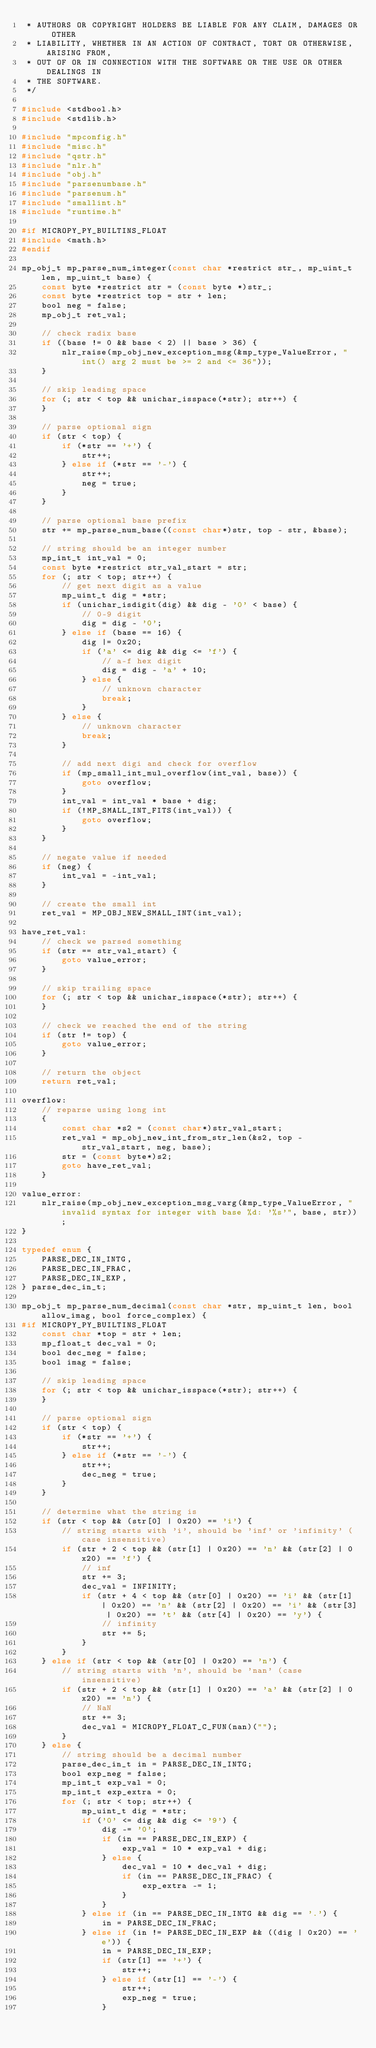Convert code to text. <code><loc_0><loc_0><loc_500><loc_500><_C_> * AUTHORS OR COPYRIGHT HOLDERS BE LIABLE FOR ANY CLAIM, DAMAGES OR OTHER
 * LIABILITY, WHETHER IN AN ACTION OF CONTRACT, TORT OR OTHERWISE, ARISING FROM,
 * OUT OF OR IN CONNECTION WITH THE SOFTWARE OR THE USE OR OTHER DEALINGS IN
 * THE SOFTWARE.
 */

#include <stdbool.h>
#include <stdlib.h>

#include "mpconfig.h"
#include "misc.h"
#include "qstr.h"
#include "nlr.h"
#include "obj.h"
#include "parsenumbase.h"
#include "parsenum.h"
#include "smallint.h"
#include "runtime.h"

#if MICROPY_PY_BUILTINS_FLOAT
#include <math.h>
#endif

mp_obj_t mp_parse_num_integer(const char *restrict str_, mp_uint_t len, mp_uint_t base) {
    const byte *restrict str = (const byte *)str_;
    const byte *restrict top = str + len;
    bool neg = false;
    mp_obj_t ret_val;

    // check radix base
    if ((base != 0 && base < 2) || base > 36) {
        nlr_raise(mp_obj_new_exception_msg(&mp_type_ValueError, "int() arg 2 must be >= 2 and <= 36"));
    }

    // skip leading space
    for (; str < top && unichar_isspace(*str); str++) {
    }

    // parse optional sign
    if (str < top) {
        if (*str == '+') {
            str++;
        } else if (*str == '-') {
            str++;
            neg = true;
        }
    }

    // parse optional base prefix
    str += mp_parse_num_base((const char*)str, top - str, &base);

    // string should be an integer number
    mp_int_t int_val = 0;
    const byte *restrict str_val_start = str;
    for (; str < top; str++) {
        // get next digit as a value
        mp_uint_t dig = *str;
        if (unichar_isdigit(dig) && dig - '0' < base) {
            // 0-9 digit
            dig = dig - '0';
        } else if (base == 16) {
            dig |= 0x20;
            if ('a' <= dig && dig <= 'f') {
                // a-f hex digit
                dig = dig - 'a' + 10;
            } else {
                // unknown character
                break;
            }
        } else {
            // unknown character
            break;
        }

        // add next digi and check for overflow
        if (mp_small_int_mul_overflow(int_val, base)) {
            goto overflow;
        }
        int_val = int_val * base + dig;
        if (!MP_SMALL_INT_FITS(int_val)) {
            goto overflow;
        }
    }

    // negate value if needed
    if (neg) {
        int_val = -int_val;
    }

    // create the small int
    ret_val = MP_OBJ_NEW_SMALL_INT(int_val);

have_ret_val:
    // check we parsed something
    if (str == str_val_start) {
        goto value_error;
    }

    // skip trailing space
    for (; str < top && unichar_isspace(*str); str++) {
    }

    // check we reached the end of the string
    if (str != top) {
        goto value_error;
    }

    // return the object
    return ret_val;

overflow:
    // reparse using long int
    {
        const char *s2 = (const char*)str_val_start;
        ret_val = mp_obj_new_int_from_str_len(&s2, top - str_val_start, neg, base);
        str = (const byte*)s2;
        goto have_ret_val;
    }

value_error:
    nlr_raise(mp_obj_new_exception_msg_varg(&mp_type_ValueError, "invalid syntax for integer with base %d: '%s'", base, str));
}

typedef enum {
    PARSE_DEC_IN_INTG,
    PARSE_DEC_IN_FRAC,
    PARSE_DEC_IN_EXP,
} parse_dec_in_t;

mp_obj_t mp_parse_num_decimal(const char *str, mp_uint_t len, bool allow_imag, bool force_complex) {
#if MICROPY_PY_BUILTINS_FLOAT
    const char *top = str + len;
    mp_float_t dec_val = 0;
    bool dec_neg = false;
    bool imag = false;

    // skip leading space
    for (; str < top && unichar_isspace(*str); str++) {
    }

    // parse optional sign
    if (str < top) {
        if (*str == '+') {
            str++;
        } else if (*str == '-') {
            str++;
            dec_neg = true;
        }
    }

    // determine what the string is
    if (str < top && (str[0] | 0x20) == 'i') {
        // string starts with 'i', should be 'inf' or 'infinity' (case insensitive)
        if (str + 2 < top && (str[1] | 0x20) == 'n' && (str[2] | 0x20) == 'f') {
            // inf
            str += 3;
            dec_val = INFINITY;
            if (str + 4 < top && (str[0] | 0x20) == 'i' && (str[1] | 0x20) == 'n' && (str[2] | 0x20) == 'i' && (str[3] | 0x20) == 't' && (str[4] | 0x20) == 'y') {
                // infinity
                str += 5;
            }
        }
    } else if (str < top && (str[0] | 0x20) == 'n') {
        // string starts with 'n', should be 'nan' (case insensitive)
        if (str + 2 < top && (str[1] | 0x20) == 'a' && (str[2] | 0x20) == 'n') {
            // NaN
            str += 3;
            dec_val = MICROPY_FLOAT_C_FUN(nan)("");
        }
    } else {
        // string should be a decimal number
        parse_dec_in_t in = PARSE_DEC_IN_INTG;
        bool exp_neg = false;
        mp_int_t exp_val = 0;
        mp_int_t exp_extra = 0;
        for (; str < top; str++) {
            mp_uint_t dig = *str;
            if ('0' <= dig && dig <= '9') {
                dig -= '0';
                if (in == PARSE_DEC_IN_EXP) {
                    exp_val = 10 * exp_val + dig;
                } else {
                    dec_val = 10 * dec_val + dig;
                    if (in == PARSE_DEC_IN_FRAC) {
                        exp_extra -= 1;
                    }
                }
            } else if (in == PARSE_DEC_IN_INTG && dig == '.') {
                in = PARSE_DEC_IN_FRAC;
            } else if (in != PARSE_DEC_IN_EXP && ((dig | 0x20) == 'e')) {
                in = PARSE_DEC_IN_EXP;
                if (str[1] == '+') {
                    str++;
                } else if (str[1] == '-') {
                    str++;
                    exp_neg = true;
                }</code> 